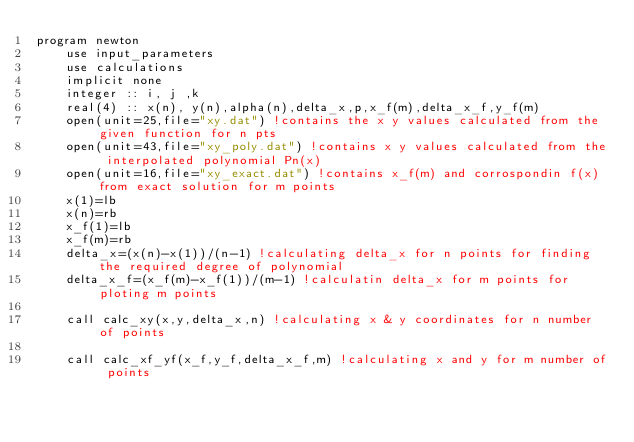<code> <loc_0><loc_0><loc_500><loc_500><_FORTRAN_>program newton
	use input_parameters
	use calculations
	implicit none
	integer :: i, j ,k
	real(4) :: x(n), y(n),alpha(n),delta_x,p,x_f(m),delta_x_f,y_f(m) 
	open(unit=25,file="xy.dat") !contains the x y values calculated from the given function for n pts
	open(unit=43,file="xy_poly.dat") !contains x y values calculated from the interpolated polynomial Pn(x)
	open(unit=16,file="xy_exact.dat") !contains x_f(m) and corrospondin f(x) from exact solution for m points
	x(1)=lb
	x(n)=rb
	x_f(1)=lb 
 	x_f(m)=rb
	delta_x=(x(n)-x(1))/(n-1) !calculating delta_x for n points for finding the required degree of polynomial
	delta_x_f=(x_f(m)-x_f(1))/(m-1) !calculatin delta_x for m points for ploting m points

	call calc_xy(x,y,delta_x,n) !calculating x & y coordinates for n number of points

	call calc_xf_yf(x_f,y_f,delta_x_f,m) !calculating x and y for m number of points 
</code> 